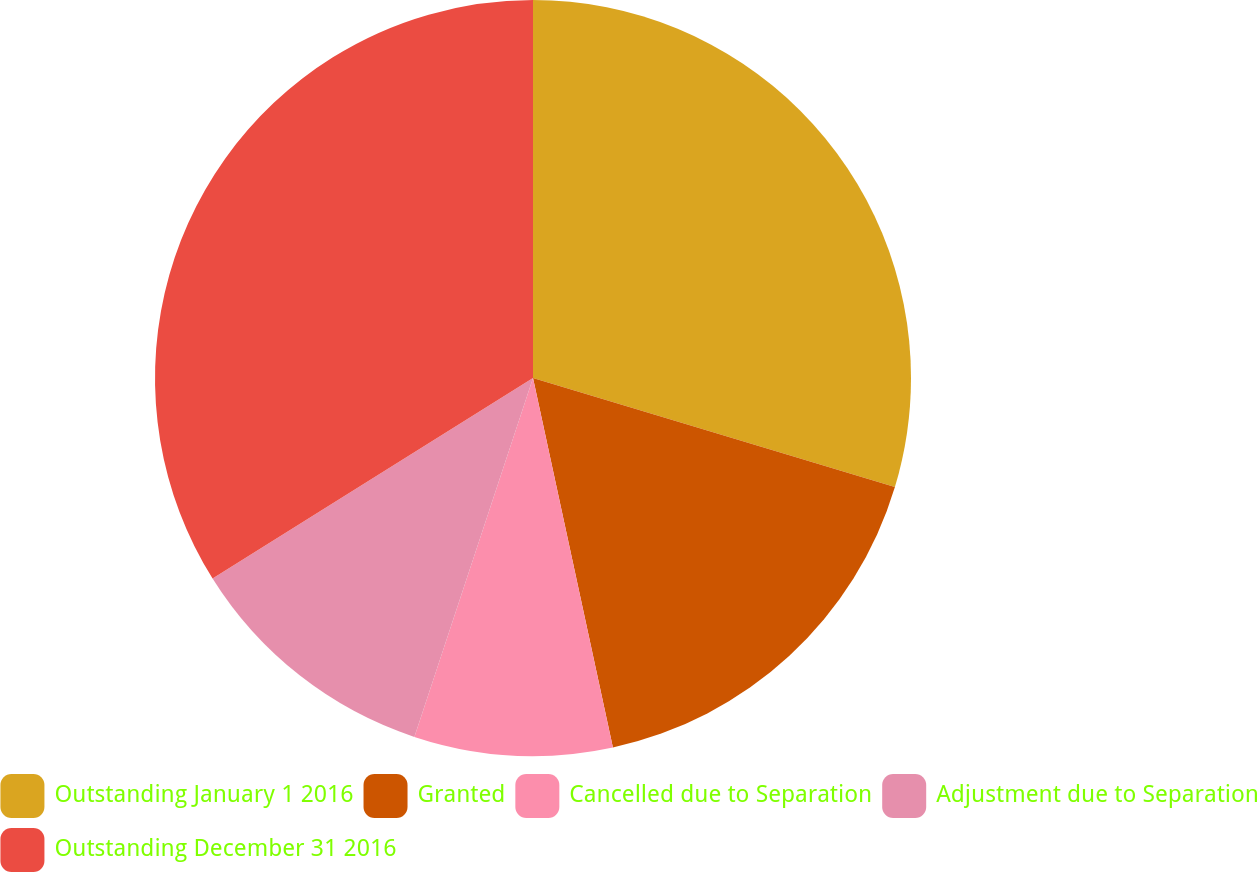<chart> <loc_0><loc_0><loc_500><loc_500><pie_chart><fcel>Outstanding January 1 2016<fcel>Granted<fcel>Cancelled due to Separation<fcel>Adjustment due to Separation<fcel>Outstanding December 31 2016<nl><fcel>29.66%<fcel>16.95%<fcel>8.47%<fcel>11.02%<fcel>33.9%<nl></chart> 